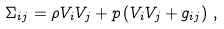<formula> <loc_0><loc_0><loc_500><loc_500>\Sigma _ { i j } = \rho \/ V _ { i } V _ { j } + p \/ \left ( V _ { i } V _ { j } + g _ { i j } \right ) \, ,</formula> 